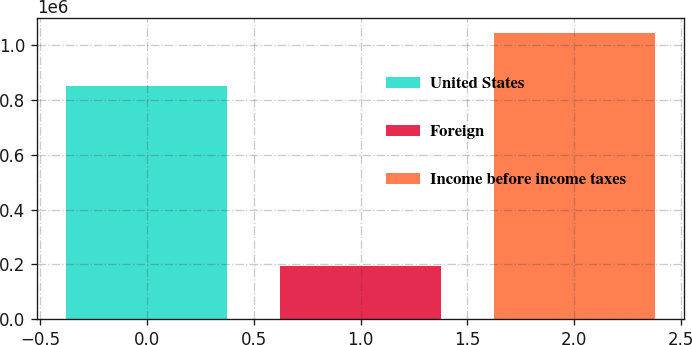Convert chart to OTSL. <chart><loc_0><loc_0><loc_500><loc_500><bar_chart><fcel>United States<fcel>Foreign<fcel>Income before income taxes<nl><fcel>850866<fcel>193438<fcel>1.0443e+06<nl></chart> 